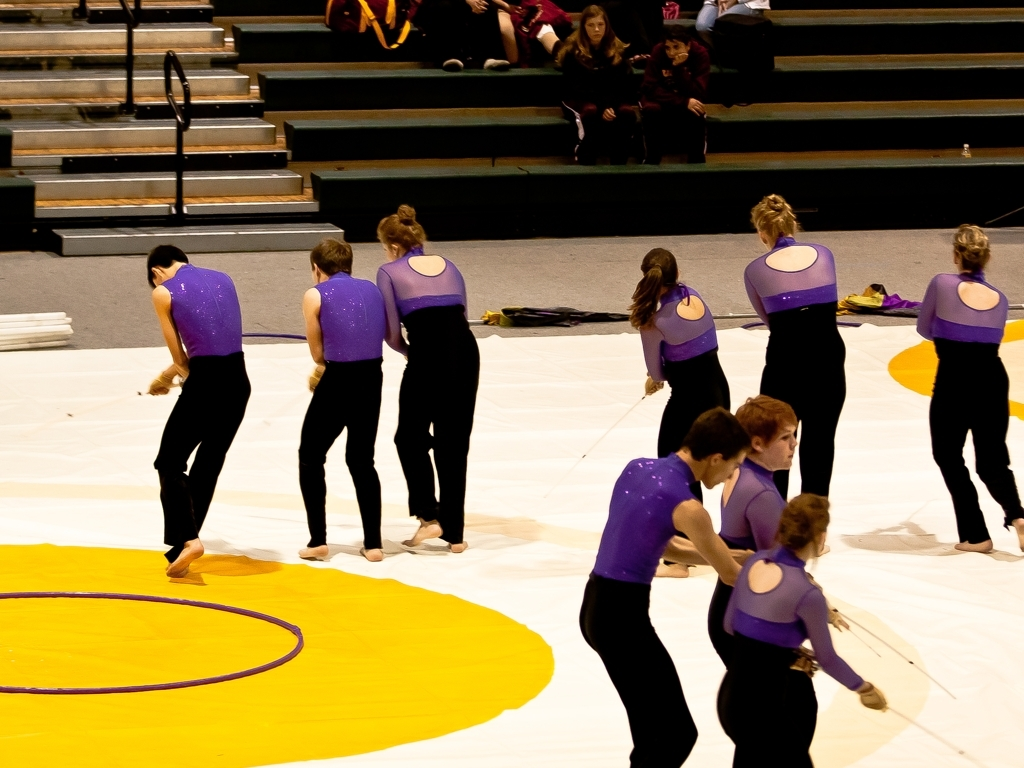Does the image lack clarity? The image is clear and the subjects are reasonably well-defined with sufficient resolution to make out details such as the performers' expressions and the patterns on the floor. 